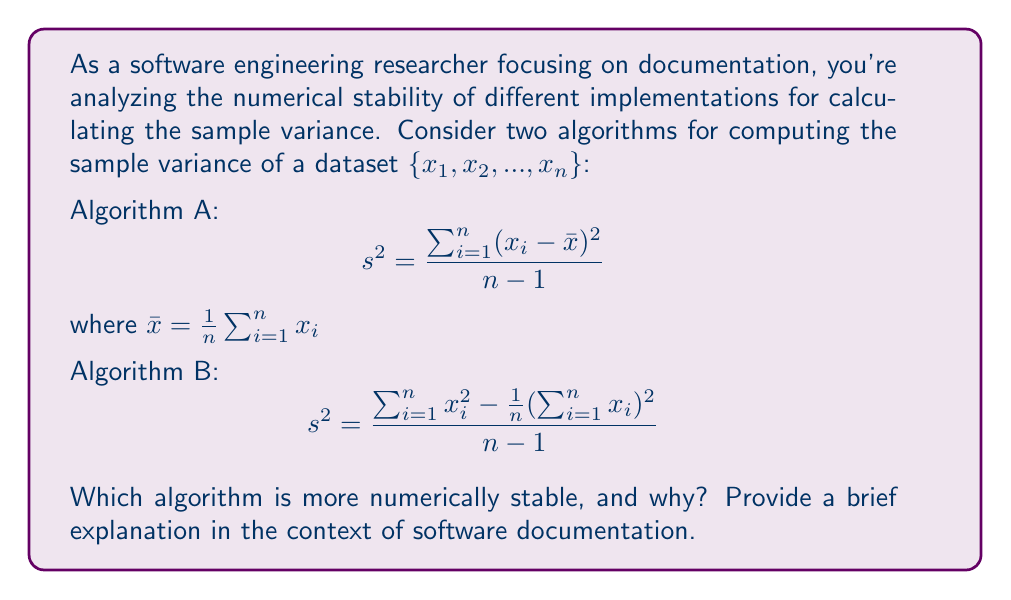What is the answer to this math problem? To evaluate the numerical stability of these algorithms, we need to consider their susceptibility to round-off errors and cancellation:

1. Algorithm A:
   - Requires two passes through the data: one to compute $\bar{x}$ and another to compute the sum of squared deviations.
   - Involves subtracting the mean from each data point, which can lead to loss of significance for datasets with large magnitudes and small variances.

2. Algorithm B:
   - Requires only one pass through the data, computing both $\sum x_i$ and $\sum x_i^2$ simultaneously.
   - Avoids the subtraction of similar numbers, reducing the risk of catastrophic cancellation.

3. Numerical stability comparison:
   - Algorithm B is generally more numerically stable, especially for large datasets or when dealing with data points of high magnitude and low variance.
   - Algorithm A can suffer from loss of precision due to the subtraction of similar numbers ($(x_i - \bar{x})$) when data points are close to the mean.

4. Software documentation context:
   - When documenting these algorithms, it's crucial to highlight the numerical stability advantages of Algorithm B.
   - Documentation should explain that Algorithm B is preferable for large datasets or when dealing with data of high magnitude and low variance.
   - It's important to note that Algorithm A, despite being less numerically stable, is more intuitive and easier to understand conceptually.

5. Practical implications:
   - In software implementations, Algorithm B should be preferred for production code where numerical stability is critical.
   - Algorithm A might be used in educational contexts or when the dataset is known to be small and well-behaved.

In conclusion, Algorithm B is more numerically stable due to its single-pass nature and reduced risk of catastrophic cancellation, making it the preferred choice for robust software implementations.
Answer: Algorithm B is more numerically stable due to reduced risk of cancellation and single-pass computation. 